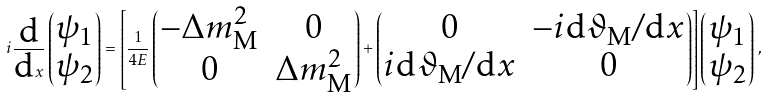<formula> <loc_0><loc_0><loc_500><loc_500>i \frac { \text {d} } { \text {d} x } \begin{pmatrix} \psi _ { 1 } \\ \psi _ { 2 } \end{pmatrix} = \left [ \frac { 1 } { 4 E } \begin{pmatrix} - \Delta { m } ^ { 2 } _ { \text {M} } & 0 \\ 0 & \Delta { m } ^ { 2 } _ { \text {M} } \end{pmatrix} + \begin{pmatrix} 0 & - i \text {d} \vartheta _ { \text {M} } / \text {d} x \\ i \text {d} \vartheta _ { \text {M} } / \text {d} x & 0 \end{pmatrix} \right ] \begin{pmatrix} \psi _ { 1 } \\ \psi _ { 2 } \end{pmatrix} \, ,</formula> 